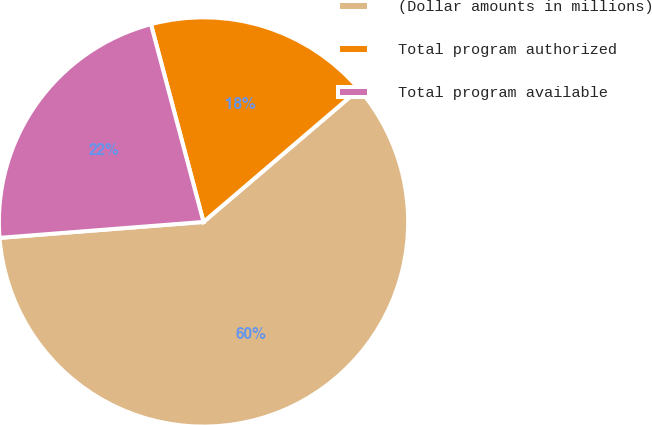Convert chart to OTSL. <chart><loc_0><loc_0><loc_500><loc_500><pie_chart><fcel>(Dollar amounts in millions)<fcel>Total program authorized<fcel>Total program available<nl><fcel>60.0%<fcel>17.89%<fcel>22.1%<nl></chart> 